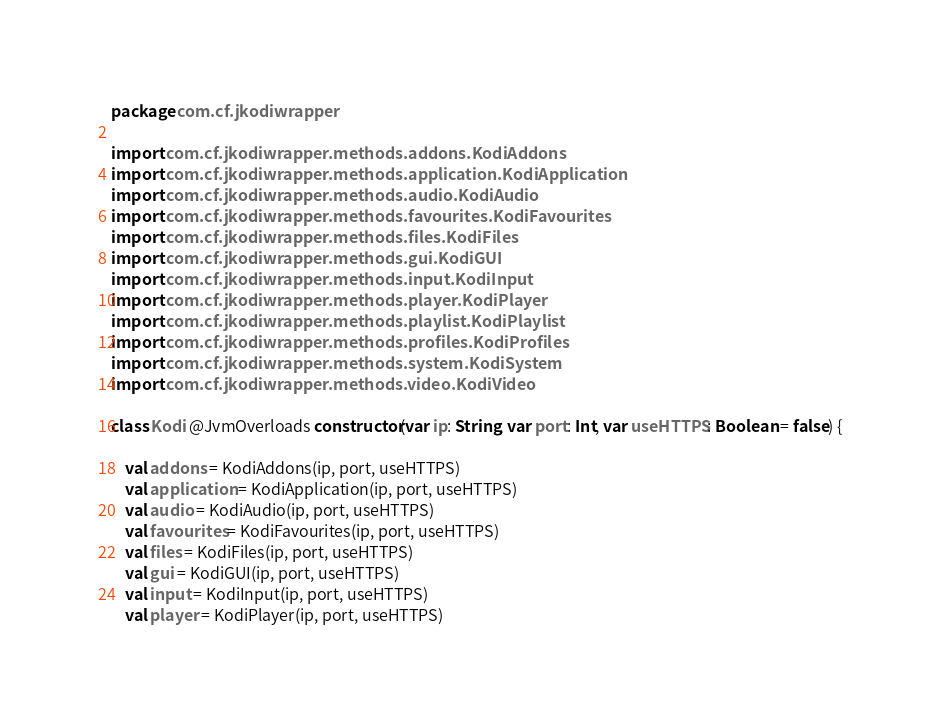<code> <loc_0><loc_0><loc_500><loc_500><_Kotlin_>package com.cf.jkodiwrapper

import com.cf.jkodiwrapper.methods.addons.KodiAddons
import com.cf.jkodiwrapper.methods.application.KodiApplication
import com.cf.jkodiwrapper.methods.audio.KodiAudio
import com.cf.jkodiwrapper.methods.favourites.KodiFavourites
import com.cf.jkodiwrapper.methods.files.KodiFiles
import com.cf.jkodiwrapper.methods.gui.KodiGUI
import com.cf.jkodiwrapper.methods.input.KodiInput
import com.cf.jkodiwrapper.methods.player.KodiPlayer
import com.cf.jkodiwrapper.methods.playlist.KodiPlaylist
import com.cf.jkodiwrapper.methods.profiles.KodiProfiles
import com.cf.jkodiwrapper.methods.system.KodiSystem
import com.cf.jkodiwrapper.methods.video.KodiVideo

class Kodi @JvmOverloads constructor(var ip: String, var port: Int, var useHTTPS: Boolean = false) {

    val addons = KodiAddons(ip, port, useHTTPS)
    val application = KodiApplication(ip, port, useHTTPS)
    val audio = KodiAudio(ip, port, useHTTPS)
    val favourites = KodiFavourites(ip, port, useHTTPS)
    val files = KodiFiles(ip, port, useHTTPS)
    val gui = KodiGUI(ip, port, useHTTPS)
    val input = KodiInput(ip, port, useHTTPS)
    val player = KodiPlayer(ip, port, useHTTPS)</code> 